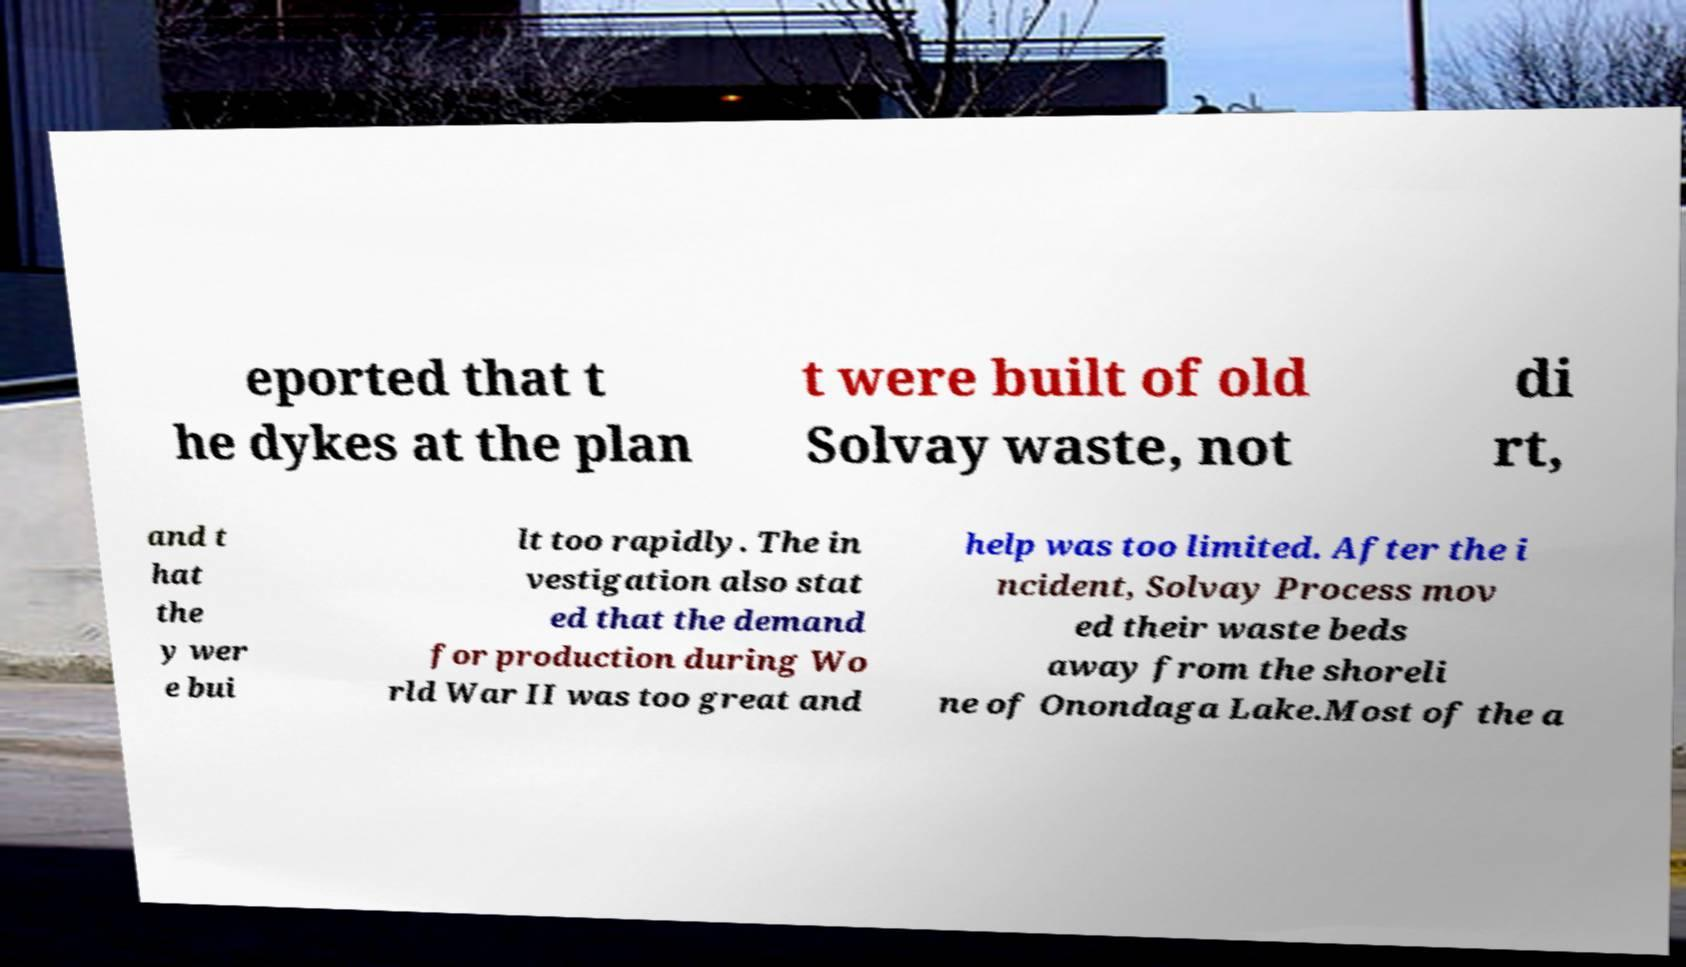Can you accurately transcribe the text from the provided image for me? eported that t he dykes at the plan t were built of old Solvay waste, not di rt, and t hat the y wer e bui lt too rapidly. The in vestigation also stat ed that the demand for production during Wo rld War II was too great and help was too limited. After the i ncident, Solvay Process mov ed their waste beds away from the shoreli ne of Onondaga Lake.Most of the a 